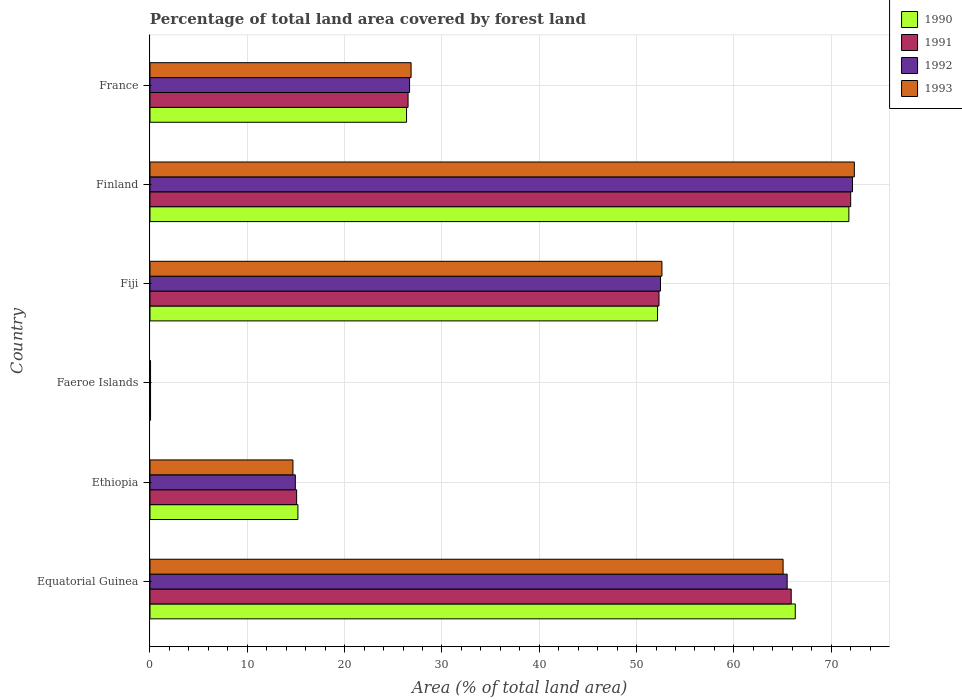How many different coloured bars are there?
Ensure brevity in your answer.  4. How many groups of bars are there?
Provide a short and direct response. 6. Are the number of bars on each tick of the Y-axis equal?
Give a very brief answer. Yes. What is the label of the 4th group of bars from the top?
Give a very brief answer. Faeroe Islands. In how many cases, is the number of bars for a given country not equal to the number of legend labels?
Keep it short and to the point. 0. What is the percentage of forest land in 1990 in Equatorial Guinea?
Your response must be concise. 66.31. Across all countries, what is the maximum percentage of forest land in 1990?
Make the answer very short. 71.82. Across all countries, what is the minimum percentage of forest land in 1993?
Offer a terse response. 0.06. In which country was the percentage of forest land in 1993 maximum?
Your answer should be very brief. Finland. In which country was the percentage of forest land in 1993 minimum?
Offer a very short reply. Faeroe Islands. What is the total percentage of forest land in 1991 in the graph?
Give a very brief answer. 231.85. What is the difference between the percentage of forest land in 1991 in Faeroe Islands and that in Fiji?
Your response must be concise. -52.25. What is the difference between the percentage of forest land in 1991 in Faeroe Islands and the percentage of forest land in 1990 in Finland?
Offer a very short reply. -71.76. What is the average percentage of forest land in 1990 per country?
Your response must be concise. 38.65. What is the difference between the percentage of forest land in 1992 and percentage of forest land in 1991 in Faeroe Islands?
Provide a succinct answer. 0. In how many countries, is the percentage of forest land in 1990 greater than 52 %?
Your answer should be very brief. 3. What is the ratio of the percentage of forest land in 1992 in Equatorial Guinea to that in Fiji?
Your answer should be very brief. 1.25. Is the percentage of forest land in 1991 in Ethiopia less than that in Finland?
Ensure brevity in your answer.  Yes. What is the difference between the highest and the second highest percentage of forest land in 1992?
Provide a short and direct response. 6.72. What is the difference between the highest and the lowest percentage of forest land in 1991?
Make the answer very short. 71.95. Is it the case that in every country, the sum of the percentage of forest land in 1990 and percentage of forest land in 1991 is greater than the sum of percentage of forest land in 1993 and percentage of forest land in 1992?
Offer a terse response. No. What does the 2nd bar from the top in Finland represents?
Provide a succinct answer. 1992. What does the 4th bar from the bottom in Ethiopia represents?
Give a very brief answer. 1993. Is it the case that in every country, the sum of the percentage of forest land in 1990 and percentage of forest land in 1992 is greater than the percentage of forest land in 1993?
Provide a short and direct response. Yes. What is the difference between two consecutive major ticks on the X-axis?
Your answer should be very brief. 10. Are the values on the major ticks of X-axis written in scientific E-notation?
Provide a succinct answer. No. Does the graph contain any zero values?
Your response must be concise. No. How many legend labels are there?
Your response must be concise. 4. How are the legend labels stacked?
Your answer should be very brief. Vertical. What is the title of the graph?
Give a very brief answer. Percentage of total land area covered by forest land. What is the label or title of the X-axis?
Your response must be concise. Area (% of total land area). What is the Area (% of total land area) in 1990 in Equatorial Guinea?
Keep it short and to the point. 66.31. What is the Area (% of total land area) of 1991 in Equatorial Guinea?
Provide a short and direct response. 65.89. What is the Area (% of total land area) in 1992 in Equatorial Guinea?
Your answer should be very brief. 65.48. What is the Area (% of total land area) of 1993 in Equatorial Guinea?
Offer a very short reply. 65.06. What is the Area (% of total land area) in 1990 in Ethiopia?
Give a very brief answer. 15.2. What is the Area (% of total land area) in 1991 in Ethiopia?
Ensure brevity in your answer.  15.07. What is the Area (% of total land area) of 1992 in Ethiopia?
Keep it short and to the point. 14.94. What is the Area (% of total land area) in 1993 in Ethiopia?
Keep it short and to the point. 14.69. What is the Area (% of total land area) of 1990 in Faeroe Islands?
Your answer should be compact. 0.06. What is the Area (% of total land area) in 1991 in Faeroe Islands?
Provide a short and direct response. 0.06. What is the Area (% of total land area) in 1992 in Faeroe Islands?
Your response must be concise. 0.06. What is the Area (% of total land area) in 1993 in Faeroe Islands?
Keep it short and to the point. 0.06. What is the Area (% of total land area) in 1990 in Fiji?
Make the answer very short. 52.16. What is the Area (% of total land area) of 1991 in Fiji?
Your answer should be compact. 52.31. What is the Area (% of total land area) in 1992 in Fiji?
Give a very brief answer. 52.46. What is the Area (% of total land area) in 1993 in Fiji?
Ensure brevity in your answer.  52.61. What is the Area (% of total land area) in 1990 in Finland?
Offer a terse response. 71.82. What is the Area (% of total land area) of 1991 in Finland?
Your response must be concise. 72. What is the Area (% of total land area) of 1992 in Finland?
Offer a terse response. 72.19. What is the Area (% of total land area) of 1993 in Finland?
Your response must be concise. 72.38. What is the Area (% of total land area) of 1990 in France?
Give a very brief answer. 26.36. What is the Area (% of total land area) in 1991 in France?
Ensure brevity in your answer.  26.52. What is the Area (% of total land area) in 1992 in France?
Provide a succinct answer. 26.68. What is the Area (% of total land area) in 1993 in France?
Give a very brief answer. 26.83. Across all countries, what is the maximum Area (% of total land area) in 1990?
Make the answer very short. 71.82. Across all countries, what is the maximum Area (% of total land area) in 1991?
Your answer should be compact. 72. Across all countries, what is the maximum Area (% of total land area) in 1992?
Ensure brevity in your answer.  72.19. Across all countries, what is the maximum Area (% of total land area) in 1993?
Your answer should be very brief. 72.38. Across all countries, what is the minimum Area (% of total land area) in 1990?
Your answer should be compact. 0.06. Across all countries, what is the minimum Area (% of total land area) of 1991?
Keep it short and to the point. 0.06. Across all countries, what is the minimum Area (% of total land area) of 1992?
Provide a short and direct response. 0.06. Across all countries, what is the minimum Area (% of total land area) in 1993?
Give a very brief answer. 0.06. What is the total Area (% of total land area) in 1990 in the graph?
Provide a succinct answer. 231.91. What is the total Area (% of total land area) in 1991 in the graph?
Offer a terse response. 231.85. What is the total Area (% of total land area) of 1992 in the graph?
Your answer should be very brief. 231.79. What is the total Area (% of total land area) in 1993 in the graph?
Make the answer very short. 231.63. What is the difference between the Area (% of total land area) in 1990 in Equatorial Guinea and that in Ethiopia?
Make the answer very short. 51.11. What is the difference between the Area (% of total land area) in 1991 in Equatorial Guinea and that in Ethiopia?
Keep it short and to the point. 50.83. What is the difference between the Area (% of total land area) of 1992 in Equatorial Guinea and that in Ethiopia?
Offer a very short reply. 50.54. What is the difference between the Area (% of total land area) of 1993 in Equatorial Guinea and that in Ethiopia?
Offer a very short reply. 50.37. What is the difference between the Area (% of total land area) in 1990 in Equatorial Guinea and that in Faeroe Islands?
Make the answer very short. 66.25. What is the difference between the Area (% of total land area) in 1991 in Equatorial Guinea and that in Faeroe Islands?
Give a very brief answer. 65.84. What is the difference between the Area (% of total land area) in 1992 in Equatorial Guinea and that in Faeroe Islands?
Your response must be concise. 65.42. What is the difference between the Area (% of total land area) of 1993 in Equatorial Guinea and that in Faeroe Islands?
Your answer should be very brief. 65. What is the difference between the Area (% of total land area) in 1990 in Equatorial Guinea and that in Fiji?
Your answer should be very brief. 14.15. What is the difference between the Area (% of total land area) in 1991 in Equatorial Guinea and that in Fiji?
Offer a terse response. 13.59. What is the difference between the Area (% of total land area) of 1992 in Equatorial Guinea and that in Fiji?
Keep it short and to the point. 13.02. What is the difference between the Area (% of total land area) in 1993 in Equatorial Guinea and that in Fiji?
Your answer should be compact. 12.45. What is the difference between the Area (% of total land area) of 1990 in Equatorial Guinea and that in Finland?
Make the answer very short. -5.51. What is the difference between the Area (% of total land area) of 1991 in Equatorial Guinea and that in Finland?
Offer a very short reply. -6.11. What is the difference between the Area (% of total land area) in 1992 in Equatorial Guinea and that in Finland?
Give a very brief answer. -6.72. What is the difference between the Area (% of total land area) of 1993 in Equatorial Guinea and that in Finland?
Your response must be concise. -7.32. What is the difference between the Area (% of total land area) of 1990 in Equatorial Guinea and that in France?
Your response must be concise. 39.95. What is the difference between the Area (% of total land area) in 1991 in Equatorial Guinea and that in France?
Ensure brevity in your answer.  39.37. What is the difference between the Area (% of total land area) in 1992 in Equatorial Guinea and that in France?
Offer a very short reply. 38.8. What is the difference between the Area (% of total land area) in 1993 in Equatorial Guinea and that in France?
Give a very brief answer. 38.23. What is the difference between the Area (% of total land area) of 1990 in Ethiopia and that in Faeroe Islands?
Your answer should be compact. 15.14. What is the difference between the Area (% of total land area) of 1991 in Ethiopia and that in Faeroe Islands?
Provide a succinct answer. 15.01. What is the difference between the Area (% of total land area) in 1992 in Ethiopia and that in Faeroe Islands?
Ensure brevity in your answer.  14.88. What is the difference between the Area (% of total land area) of 1993 in Ethiopia and that in Faeroe Islands?
Provide a short and direct response. 14.63. What is the difference between the Area (% of total land area) in 1990 in Ethiopia and that in Fiji?
Keep it short and to the point. -36.96. What is the difference between the Area (% of total land area) in 1991 in Ethiopia and that in Fiji?
Provide a succinct answer. -37.24. What is the difference between the Area (% of total land area) of 1992 in Ethiopia and that in Fiji?
Offer a terse response. -37.52. What is the difference between the Area (% of total land area) in 1993 in Ethiopia and that in Fiji?
Make the answer very short. -37.92. What is the difference between the Area (% of total land area) of 1990 in Ethiopia and that in Finland?
Make the answer very short. -56.62. What is the difference between the Area (% of total land area) of 1991 in Ethiopia and that in Finland?
Offer a terse response. -56.94. What is the difference between the Area (% of total land area) in 1992 in Ethiopia and that in Finland?
Provide a short and direct response. -57.26. What is the difference between the Area (% of total land area) in 1993 in Ethiopia and that in Finland?
Offer a very short reply. -57.69. What is the difference between the Area (% of total land area) of 1990 in Ethiopia and that in France?
Your response must be concise. -11.16. What is the difference between the Area (% of total land area) of 1991 in Ethiopia and that in France?
Ensure brevity in your answer.  -11.45. What is the difference between the Area (% of total land area) of 1992 in Ethiopia and that in France?
Make the answer very short. -11.74. What is the difference between the Area (% of total land area) in 1993 in Ethiopia and that in France?
Ensure brevity in your answer.  -12.14. What is the difference between the Area (% of total land area) of 1990 in Faeroe Islands and that in Fiji?
Offer a terse response. -52.1. What is the difference between the Area (% of total land area) of 1991 in Faeroe Islands and that in Fiji?
Your answer should be compact. -52.25. What is the difference between the Area (% of total land area) in 1992 in Faeroe Islands and that in Fiji?
Keep it short and to the point. -52.4. What is the difference between the Area (% of total land area) in 1993 in Faeroe Islands and that in Fiji?
Give a very brief answer. -52.55. What is the difference between the Area (% of total land area) in 1990 in Faeroe Islands and that in Finland?
Your answer should be very brief. -71.76. What is the difference between the Area (% of total land area) in 1991 in Faeroe Islands and that in Finland?
Give a very brief answer. -71.95. What is the difference between the Area (% of total land area) of 1992 in Faeroe Islands and that in Finland?
Provide a succinct answer. -72.13. What is the difference between the Area (% of total land area) of 1993 in Faeroe Islands and that in Finland?
Make the answer very short. -72.32. What is the difference between the Area (% of total land area) of 1990 in Faeroe Islands and that in France?
Your response must be concise. -26.31. What is the difference between the Area (% of total land area) in 1991 in Faeroe Islands and that in France?
Your answer should be compact. -26.46. What is the difference between the Area (% of total land area) in 1992 in Faeroe Islands and that in France?
Ensure brevity in your answer.  -26.62. What is the difference between the Area (% of total land area) in 1993 in Faeroe Islands and that in France?
Provide a short and direct response. -26.77. What is the difference between the Area (% of total land area) of 1990 in Fiji and that in Finland?
Your answer should be compact. -19.66. What is the difference between the Area (% of total land area) of 1991 in Fiji and that in Finland?
Keep it short and to the point. -19.7. What is the difference between the Area (% of total land area) in 1992 in Fiji and that in Finland?
Make the answer very short. -19.73. What is the difference between the Area (% of total land area) in 1993 in Fiji and that in Finland?
Your response must be concise. -19.77. What is the difference between the Area (% of total land area) of 1990 in Fiji and that in France?
Make the answer very short. 25.79. What is the difference between the Area (% of total land area) of 1991 in Fiji and that in France?
Your response must be concise. 25.79. What is the difference between the Area (% of total land area) of 1992 in Fiji and that in France?
Keep it short and to the point. 25.78. What is the difference between the Area (% of total land area) of 1993 in Fiji and that in France?
Offer a terse response. 25.78. What is the difference between the Area (% of total land area) in 1990 in Finland and that in France?
Your answer should be very brief. 45.45. What is the difference between the Area (% of total land area) in 1991 in Finland and that in France?
Give a very brief answer. 45.49. What is the difference between the Area (% of total land area) of 1992 in Finland and that in France?
Offer a terse response. 45.52. What is the difference between the Area (% of total land area) of 1993 in Finland and that in France?
Offer a terse response. 45.55. What is the difference between the Area (% of total land area) in 1990 in Equatorial Guinea and the Area (% of total land area) in 1991 in Ethiopia?
Provide a succinct answer. 51.24. What is the difference between the Area (% of total land area) in 1990 in Equatorial Guinea and the Area (% of total land area) in 1992 in Ethiopia?
Provide a succinct answer. 51.37. What is the difference between the Area (% of total land area) of 1990 in Equatorial Guinea and the Area (% of total land area) of 1993 in Ethiopia?
Provide a short and direct response. 51.62. What is the difference between the Area (% of total land area) of 1991 in Equatorial Guinea and the Area (% of total land area) of 1992 in Ethiopia?
Your answer should be very brief. 50.96. What is the difference between the Area (% of total land area) of 1991 in Equatorial Guinea and the Area (% of total land area) of 1993 in Ethiopia?
Your answer should be compact. 51.2. What is the difference between the Area (% of total land area) in 1992 in Equatorial Guinea and the Area (% of total land area) in 1993 in Ethiopia?
Give a very brief answer. 50.78. What is the difference between the Area (% of total land area) of 1990 in Equatorial Guinea and the Area (% of total land area) of 1991 in Faeroe Islands?
Offer a very short reply. 66.25. What is the difference between the Area (% of total land area) of 1990 in Equatorial Guinea and the Area (% of total land area) of 1992 in Faeroe Islands?
Give a very brief answer. 66.25. What is the difference between the Area (% of total land area) in 1990 in Equatorial Guinea and the Area (% of total land area) in 1993 in Faeroe Islands?
Your answer should be very brief. 66.25. What is the difference between the Area (% of total land area) of 1991 in Equatorial Guinea and the Area (% of total land area) of 1992 in Faeroe Islands?
Your response must be concise. 65.84. What is the difference between the Area (% of total land area) of 1991 in Equatorial Guinea and the Area (% of total land area) of 1993 in Faeroe Islands?
Give a very brief answer. 65.84. What is the difference between the Area (% of total land area) of 1992 in Equatorial Guinea and the Area (% of total land area) of 1993 in Faeroe Islands?
Keep it short and to the point. 65.42. What is the difference between the Area (% of total land area) of 1990 in Equatorial Guinea and the Area (% of total land area) of 1991 in Fiji?
Your answer should be very brief. 14. What is the difference between the Area (% of total land area) of 1990 in Equatorial Guinea and the Area (% of total land area) of 1992 in Fiji?
Keep it short and to the point. 13.85. What is the difference between the Area (% of total land area) in 1990 in Equatorial Guinea and the Area (% of total land area) in 1993 in Fiji?
Your answer should be compact. 13.7. What is the difference between the Area (% of total land area) in 1991 in Equatorial Guinea and the Area (% of total land area) in 1992 in Fiji?
Keep it short and to the point. 13.43. What is the difference between the Area (% of total land area) in 1991 in Equatorial Guinea and the Area (% of total land area) in 1993 in Fiji?
Your answer should be compact. 13.28. What is the difference between the Area (% of total land area) of 1992 in Equatorial Guinea and the Area (% of total land area) of 1993 in Fiji?
Your answer should be compact. 12.87. What is the difference between the Area (% of total land area) of 1990 in Equatorial Guinea and the Area (% of total land area) of 1991 in Finland?
Your response must be concise. -5.69. What is the difference between the Area (% of total land area) in 1990 in Equatorial Guinea and the Area (% of total land area) in 1992 in Finland?
Your response must be concise. -5.88. What is the difference between the Area (% of total land area) in 1990 in Equatorial Guinea and the Area (% of total land area) in 1993 in Finland?
Keep it short and to the point. -6.07. What is the difference between the Area (% of total land area) of 1991 in Equatorial Guinea and the Area (% of total land area) of 1992 in Finland?
Make the answer very short. -6.3. What is the difference between the Area (% of total land area) in 1991 in Equatorial Guinea and the Area (% of total land area) in 1993 in Finland?
Make the answer very short. -6.49. What is the difference between the Area (% of total land area) of 1992 in Equatorial Guinea and the Area (% of total land area) of 1993 in Finland?
Keep it short and to the point. -6.9. What is the difference between the Area (% of total land area) of 1990 in Equatorial Guinea and the Area (% of total land area) of 1991 in France?
Make the answer very short. 39.79. What is the difference between the Area (% of total land area) in 1990 in Equatorial Guinea and the Area (% of total land area) in 1992 in France?
Make the answer very short. 39.63. What is the difference between the Area (% of total land area) in 1990 in Equatorial Guinea and the Area (% of total land area) in 1993 in France?
Make the answer very short. 39.48. What is the difference between the Area (% of total land area) of 1991 in Equatorial Guinea and the Area (% of total land area) of 1992 in France?
Your answer should be very brief. 39.22. What is the difference between the Area (% of total land area) of 1991 in Equatorial Guinea and the Area (% of total land area) of 1993 in France?
Provide a short and direct response. 39.06. What is the difference between the Area (% of total land area) in 1992 in Equatorial Guinea and the Area (% of total land area) in 1993 in France?
Ensure brevity in your answer.  38.64. What is the difference between the Area (% of total land area) of 1990 in Ethiopia and the Area (% of total land area) of 1991 in Faeroe Islands?
Your answer should be very brief. 15.14. What is the difference between the Area (% of total land area) in 1990 in Ethiopia and the Area (% of total land area) in 1992 in Faeroe Islands?
Your answer should be very brief. 15.14. What is the difference between the Area (% of total land area) in 1990 in Ethiopia and the Area (% of total land area) in 1993 in Faeroe Islands?
Give a very brief answer. 15.14. What is the difference between the Area (% of total land area) in 1991 in Ethiopia and the Area (% of total land area) in 1992 in Faeroe Islands?
Your response must be concise. 15.01. What is the difference between the Area (% of total land area) in 1991 in Ethiopia and the Area (% of total land area) in 1993 in Faeroe Islands?
Offer a very short reply. 15.01. What is the difference between the Area (% of total land area) in 1992 in Ethiopia and the Area (% of total land area) in 1993 in Faeroe Islands?
Your response must be concise. 14.88. What is the difference between the Area (% of total land area) in 1990 in Ethiopia and the Area (% of total land area) in 1991 in Fiji?
Give a very brief answer. -37.11. What is the difference between the Area (% of total land area) of 1990 in Ethiopia and the Area (% of total land area) of 1992 in Fiji?
Offer a terse response. -37.26. What is the difference between the Area (% of total land area) in 1990 in Ethiopia and the Area (% of total land area) in 1993 in Fiji?
Ensure brevity in your answer.  -37.41. What is the difference between the Area (% of total land area) in 1991 in Ethiopia and the Area (% of total land area) in 1992 in Fiji?
Offer a terse response. -37.39. What is the difference between the Area (% of total land area) of 1991 in Ethiopia and the Area (% of total land area) of 1993 in Fiji?
Your response must be concise. -37.54. What is the difference between the Area (% of total land area) of 1992 in Ethiopia and the Area (% of total land area) of 1993 in Fiji?
Keep it short and to the point. -37.67. What is the difference between the Area (% of total land area) in 1990 in Ethiopia and the Area (% of total land area) in 1991 in Finland?
Your answer should be compact. -56.81. What is the difference between the Area (% of total land area) of 1990 in Ethiopia and the Area (% of total land area) of 1992 in Finland?
Offer a very short reply. -56.99. What is the difference between the Area (% of total land area) in 1990 in Ethiopia and the Area (% of total land area) in 1993 in Finland?
Your response must be concise. -57.18. What is the difference between the Area (% of total land area) of 1991 in Ethiopia and the Area (% of total land area) of 1992 in Finland?
Your response must be concise. -57.12. What is the difference between the Area (% of total land area) of 1991 in Ethiopia and the Area (% of total land area) of 1993 in Finland?
Your response must be concise. -57.31. What is the difference between the Area (% of total land area) of 1992 in Ethiopia and the Area (% of total land area) of 1993 in Finland?
Give a very brief answer. -57.44. What is the difference between the Area (% of total land area) in 1990 in Ethiopia and the Area (% of total land area) in 1991 in France?
Offer a terse response. -11.32. What is the difference between the Area (% of total land area) of 1990 in Ethiopia and the Area (% of total land area) of 1992 in France?
Give a very brief answer. -11.48. What is the difference between the Area (% of total land area) in 1990 in Ethiopia and the Area (% of total land area) in 1993 in France?
Offer a very short reply. -11.63. What is the difference between the Area (% of total land area) in 1991 in Ethiopia and the Area (% of total land area) in 1992 in France?
Offer a terse response. -11.61. What is the difference between the Area (% of total land area) in 1991 in Ethiopia and the Area (% of total land area) in 1993 in France?
Provide a succinct answer. -11.76. What is the difference between the Area (% of total land area) of 1992 in Ethiopia and the Area (% of total land area) of 1993 in France?
Provide a short and direct response. -11.9. What is the difference between the Area (% of total land area) of 1990 in Faeroe Islands and the Area (% of total land area) of 1991 in Fiji?
Your response must be concise. -52.25. What is the difference between the Area (% of total land area) of 1990 in Faeroe Islands and the Area (% of total land area) of 1992 in Fiji?
Provide a succinct answer. -52.4. What is the difference between the Area (% of total land area) of 1990 in Faeroe Islands and the Area (% of total land area) of 1993 in Fiji?
Ensure brevity in your answer.  -52.55. What is the difference between the Area (% of total land area) of 1991 in Faeroe Islands and the Area (% of total land area) of 1992 in Fiji?
Give a very brief answer. -52.4. What is the difference between the Area (% of total land area) of 1991 in Faeroe Islands and the Area (% of total land area) of 1993 in Fiji?
Keep it short and to the point. -52.55. What is the difference between the Area (% of total land area) of 1992 in Faeroe Islands and the Area (% of total land area) of 1993 in Fiji?
Your response must be concise. -52.55. What is the difference between the Area (% of total land area) in 1990 in Faeroe Islands and the Area (% of total land area) in 1991 in Finland?
Offer a very short reply. -71.95. What is the difference between the Area (% of total land area) of 1990 in Faeroe Islands and the Area (% of total land area) of 1992 in Finland?
Provide a succinct answer. -72.13. What is the difference between the Area (% of total land area) in 1990 in Faeroe Islands and the Area (% of total land area) in 1993 in Finland?
Your answer should be compact. -72.32. What is the difference between the Area (% of total land area) of 1991 in Faeroe Islands and the Area (% of total land area) of 1992 in Finland?
Keep it short and to the point. -72.13. What is the difference between the Area (% of total land area) in 1991 in Faeroe Islands and the Area (% of total land area) in 1993 in Finland?
Offer a very short reply. -72.32. What is the difference between the Area (% of total land area) in 1992 in Faeroe Islands and the Area (% of total land area) in 1993 in Finland?
Keep it short and to the point. -72.32. What is the difference between the Area (% of total land area) of 1990 in Faeroe Islands and the Area (% of total land area) of 1991 in France?
Make the answer very short. -26.46. What is the difference between the Area (% of total land area) of 1990 in Faeroe Islands and the Area (% of total land area) of 1992 in France?
Your answer should be very brief. -26.62. What is the difference between the Area (% of total land area) in 1990 in Faeroe Islands and the Area (% of total land area) in 1993 in France?
Provide a succinct answer. -26.77. What is the difference between the Area (% of total land area) in 1991 in Faeroe Islands and the Area (% of total land area) in 1992 in France?
Your response must be concise. -26.62. What is the difference between the Area (% of total land area) in 1991 in Faeroe Islands and the Area (% of total land area) in 1993 in France?
Your response must be concise. -26.77. What is the difference between the Area (% of total land area) of 1992 in Faeroe Islands and the Area (% of total land area) of 1993 in France?
Your response must be concise. -26.77. What is the difference between the Area (% of total land area) of 1990 in Fiji and the Area (% of total land area) of 1991 in Finland?
Provide a succinct answer. -19.85. What is the difference between the Area (% of total land area) of 1990 in Fiji and the Area (% of total land area) of 1992 in Finland?
Provide a succinct answer. -20.04. What is the difference between the Area (% of total land area) of 1990 in Fiji and the Area (% of total land area) of 1993 in Finland?
Your answer should be very brief. -20.22. What is the difference between the Area (% of total land area) in 1991 in Fiji and the Area (% of total land area) in 1992 in Finland?
Make the answer very short. -19.89. What is the difference between the Area (% of total land area) of 1991 in Fiji and the Area (% of total land area) of 1993 in Finland?
Offer a terse response. -20.07. What is the difference between the Area (% of total land area) in 1992 in Fiji and the Area (% of total land area) in 1993 in Finland?
Make the answer very short. -19.92. What is the difference between the Area (% of total land area) in 1990 in Fiji and the Area (% of total land area) in 1991 in France?
Give a very brief answer. 25.64. What is the difference between the Area (% of total land area) in 1990 in Fiji and the Area (% of total land area) in 1992 in France?
Provide a short and direct response. 25.48. What is the difference between the Area (% of total land area) in 1990 in Fiji and the Area (% of total land area) in 1993 in France?
Offer a terse response. 25.33. What is the difference between the Area (% of total land area) of 1991 in Fiji and the Area (% of total land area) of 1992 in France?
Your answer should be compact. 25.63. What is the difference between the Area (% of total land area) of 1991 in Fiji and the Area (% of total land area) of 1993 in France?
Your answer should be compact. 25.48. What is the difference between the Area (% of total land area) in 1992 in Fiji and the Area (% of total land area) in 1993 in France?
Your answer should be very brief. 25.63. What is the difference between the Area (% of total land area) in 1990 in Finland and the Area (% of total land area) in 1991 in France?
Make the answer very short. 45.3. What is the difference between the Area (% of total land area) in 1990 in Finland and the Area (% of total land area) in 1992 in France?
Your answer should be very brief. 45.14. What is the difference between the Area (% of total land area) in 1990 in Finland and the Area (% of total land area) in 1993 in France?
Your response must be concise. 44.99. What is the difference between the Area (% of total land area) of 1991 in Finland and the Area (% of total land area) of 1992 in France?
Your response must be concise. 45.33. What is the difference between the Area (% of total land area) in 1991 in Finland and the Area (% of total land area) in 1993 in France?
Make the answer very short. 45.17. What is the difference between the Area (% of total land area) in 1992 in Finland and the Area (% of total land area) in 1993 in France?
Offer a terse response. 45.36. What is the average Area (% of total land area) in 1990 per country?
Give a very brief answer. 38.65. What is the average Area (% of total land area) in 1991 per country?
Offer a terse response. 38.64. What is the average Area (% of total land area) of 1992 per country?
Give a very brief answer. 38.63. What is the average Area (% of total land area) of 1993 per country?
Your answer should be very brief. 38.6. What is the difference between the Area (% of total land area) in 1990 and Area (% of total land area) in 1991 in Equatorial Guinea?
Your answer should be compact. 0.42. What is the difference between the Area (% of total land area) in 1990 and Area (% of total land area) in 1992 in Equatorial Guinea?
Your answer should be very brief. 0.83. What is the difference between the Area (% of total land area) in 1990 and Area (% of total land area) in 1993 in Equatorial Guinea?
Your answer should be compact. 1.25. What is the difference between the Area (% of total land area) in 1991 and Area (% of total land area) in 1992 in Equatorial Guinea?
Your answer should be compact. 0.42. What is the difference between the Area (% of total land area) of 1991 and Area (% of total land area) of 1993 in Equatorial Guinea?
Make the answer very short. 0.83. What is the difference between the Area (% of total land area) in 1992 and Area (% of total land area) in 1993 in Equatorial Guinea?
Provide a short and direct response. 0.42. What is the difference between the Area (% of total land area) of 1990 and Area (% of total land area) of 1991 in Ethiopia?
Keep it short and to the point. 0.13. What is the difference between the Area (% of total land area) in 1990 and Area (% of total land area) in 1992 in Ethiopia?
Ensure brevity in your answer.  0.26. What is the difference between the Area (% of total land area) of 1990 and Area (% of total land area) of 1993 in Ethiopia?
Give a very brief answer. 0.51. What is the difference between the Area (% of total land area) in 1991 and Area (% of total land area) in 1992 in Ethiopia?
Offer a very short reply. 0.13. What is the difference between the Area (% of total land area) in 1991 and Area (% of total land area) in 1993 in Ethiopia?
Give a very brief answer. 0.38. What is the difference between the Area (% of total land area) in 1992 and Area (% of total land area) in 1993 in Ethiopia?
Your response must be concise. 0.24. What is the difference between the Area (% of total land area) in 1990 and Area (% of total land area) in 1992 in Faeroe Islands?
Your answer should be very brief. 0. What is the difference between the Area (% of total land area) of 1991 and Area (% of total land area) of 1992 in Faeroe Islands?
Offer a terse response. 0. What is the difference between the Area (% of total land area) in 1991 and Area (% of total land area) in 1993 in Faeroe Islands?
Ensure brevity in your answer.  0. What is the difference between the Area (% of total land area) in 1990 and Area (% of total land area) in 1991 in Fiji?
Offer a very short reply. -0.15. What is the difference between the Area (% of total land area) of 1990 and Area (% of total land area) of 1992 in Fiji?
Offer a terse response. -0.3. What is the difference between the Area (% of total land area) of 1990 and Area (% of total land area) of 1993 in Fiji?
Ensure brevity in your answer.  -0.45. What is the difference between the Area (% of total land area) in 1991 and Area (% of total land area) in 1992 in Fiji?
Ensure brevity in your answer.  -0.15. What is the difference between the Area (% of total land area) in 1991 and Area (% of total land area) in 1993 in Fiji?
Offer a terse response. -0.3. What is the difference between the Area (% of total land area) in 1992 and Area (% of total land area) in 1993 in Fiji?
Make the answer very short. -0.15. What is the difference between the Area (% of total land area) in 1990 and Area (% of total land area) in 1991 in Finland?
Ensure brevity in your answer.  -0.19. What is the difference between the Area (% of total land area) in 1990 and Area (% of total land area) in 1992 in Finland?
Your answer should be compact. -0.37. What is the difference between the Area (% of total land area) in 1990 and Area (% of total land area) in 1993 in Finland?
Your answer should be compact. -0.56. What is the difference between the Area (% of total land area) in 1991 and Area (% of total land area) in 1992 in Finland?
Make the answer very short. -0.19. What is the difference between the Area (% of total land area) of 1991 and Area (% of total land area) of 1993 in Finland?
Your answer should be very brief. -0.37. What is the difference between the Area (% of total land area) in 1992 and Area (% of total land area) in 1993 in Finland?
Provide a succinct answer. -0.19. What is the difference between the Area (% of total land area) of 1990 and Area (% of total land area) of 1991 in France?
Provide a succinct answer. -0.16. What is the difference between the Area (% of total land area) of 1990 and Area (% of total land area) of 1992 in France?
Provide a succinct answer. -0.31. What is the difference between the Area (% of total land area) in 1990 and Area (% of total land area) in 1993 in France?
Your response must be concise. -0.47. What is the difference between the Area (% of total land area) in 1991 and Area (% of total land area) in 1992 in France?
Provide a succinct answer. -0.16. What is the difference between the Area (% of total land area) in 1991 and Area (% of total land area) in 1993 in France?
Your answer should be compact. -0.31. What is the difference between the Area (% of total land area) of 1992 and Area (% of total land area) of 1993 in France?
Ensure brevity in your answer.  -0.16. What is the ratio of the Area (% of total land area) in 1990 in Equatorial Guinea to that in Ethiopia?
Your answer should be very brief. 4.36. What is the ratio of the Area (% of total land area) in 1991 in Equatorial Guinea to that in Ethiopia?
Ensure brevity in your answer.  4.37. What is the ratio of the Area (% of total land area) of 1992 in Equatorial Guinea to that in Ethiopia?
Provide a succinct answer. 4.38. What is the ratio of the Area (% of total land area) of 1993 in Equatorial Guinea to that in Ethiopia?
Your answer should be very brief. 4.43. What is the ratio of the Area (% of total land area) in 1990 in Equatorial Guinea to that in Faeroe Islands?
Your answer should be very brief. 1157.11. What is the ratio of the Area (% of total land area) of 1991 in Equatorial Guinea to that in Faeroe Islands?
Provide a succinct answer. 1149.83. What is the ratio of the Area (% of total land area) in 1992 in Equatorial Guinea to that in Faeroe Islands?
Offer a terse response. 1142.56. What is the ratio of the Area (% of total land area) in 1993 in Equatorial Guinea to that in Faeroe Islands?
Your response must be concise. 1135.28. What is the ratio of the Area (% of total land area) in 1990 in Equatorial Guinea to that in Fiji?
Give a very brief answer. 1.27. What is the ratio of the Area (% of total land area) in 1991 in Equatorial Guinea to that in Fiji?
Ensure brevity in your answer.  1.26. What is the ratio of the Area (% of total land area) in 1992 in Equatorial Guinea to that in Fiji?
Ensure brevity in your answer.  1.25. What is the ratio of the Area (% of total land area) in 1993 in Equatorial Guinea to that in Fiji?
Provide a short and direct response. 1.24. What is the ratio of the Area (% of total land area) of 1990 in Equatorial Guinea to that in Finland?
Offer a terse response. 0.92. What is the ratio of the Area (% of total land area) of 1991 in Equatorial Guinea to that in Finland?
Provide a succinct answer. 0.92. What is the ratio of the Area (% of total land area) of 1992 in Equatorial Guinea to that in Finland?
Make the answer very short. 0.91. What is the ratio of the Area (% of total land area) of 1993 in Equatorial Guinea to that in Finland?
Your answer should be compact. 0.9. What is the ratio of the Area (% of total land area) in 1990 in Equatorial Guinea to that in France?
Provide a short and direct response. 2.52. What is the ratio of the Area (% of total land area) of 1991 in Equatorial Guinea to that in France?
Keep it short and to the point. 2.48. What is the ratio of the Area (% of total land area) in 1992 in Equatorial Guinea to that in France?
Keep it short and to the point. 2.45. What is the ratio of the Area (% of total land area) of 1993 in Equatorial Guinea to that in France?
Provide a succinct answer. 2.42. What is the ratio of the Area (% of total land area) in 1990 in Ethiopia to that in Faeroe Islands?
Offer a very short reply. 265.24. What is the ratio of the Area (% of total land area) of 1991 in Ethiopia to that in Faeroe Islands?
Offer a very short reply. 262.93. What is the ratio of the Area (% of total land area) of 1992 in Ethiopia to that in Faeroe Islands?
Keep it short and to the point. 260.63. What is the ratio of the Area (% of total land area) of 1993 in Ethiopia to that in Faeroe Islands?
Keep it short and to the point. 256.36. What is the ratio of the Area (% of total land area) of 1990 in Ethiopia to that in Fiji?
Offer a terse response. 0.29. What is the ratio of the Area (% of total land area) in 1991 in Ethiopia to that in Fiji?
Ensure brevity in your answer.  0.29. What is the ratio of the Area (% of total land area) in 1992 in Ethiopia to that in Fiji?
Provide a succinct answer. 0.28. What is the ratio of the Area (% of total land area) of 1993 in Ethiopia to that in Fiji?
Provide a short and direct response. 0.28. What is the ratio of the Area (% of total land area) in 1990 in Ethiopia to that in Finland?
Keep it short and to the point. 0.21. What is the ratio of the Area (% of total land area) of 1991 in Ethiopia to that in Finland?
Your answer should be very brief. 0.21. What is the ratio of the Area (% of total land area) in 1992 in Ethiopia to that in Finland?
Your answer should be very brief. 0.21. What is the ratio of the Area (% of total land area) in 1993 in Ethiopia to that in Finland?
Keep it short and to the point. 0.2. What is the ratio of the Area (% of total land area) in 1990 in Ethiopia to that in France?
Provide a succinct answer. 0.58. What is the ratio of the Area (% of total land area) of 1991 in Ethiopia to that in France?
Your response must be concise. 0.57. What is the ratio of the Area (% of total land area) of 1992 in Ethiopia to that in France?
Give a very brief answer. 0.56. What is the ratio of the Area (% of total land area) in 1993 in Ethiopia to that in France?
Keep it short and to the point. 0.55. What is the ratio of the Area (% of total land area) in 1990 in Faeroe Islands to that in Fiji?
Make the answer very short. 0. What is the ratio of the Area (% of total land area) of 1991 in Faeroe Islands to that in Fiji?
Give a very brief answer. 0. What is the ratio of the Area (% of total land area) in 1992 in Faeroe Islands to that in Fiji?
Your answer should be compact. 0. What is the ratio of the Area (% of total land area) in 1993 in Faeroe Islands to that in Fiji?
Provide a succinct answer. 0. What is the ratio of the Area (% of total land area) in 1990 in Faeroe Islands to that in Finland?
Ensure brevity in your answer.  0. What is the ratio of the Area (% of total land area) in 1991 in Faeroe Islands to that in Finland?
Your answer should be very brief. 0. What is the ratio of the Area (% of total land area) in 1992 in Faeroe Islands to that in Finland?
Your answer should be very brief. 0. What is the ratio of the Area (% of total land area) of 1993 in Faeroe Islands to that in Finland?
Keep it short and to the point. 0. What is the ratio of the Area (% of total land area) of 1990 in Faeroe Islands to that in France?
Provide a succinct answer. 0. What is the ratio of the Area (% of total land area) of 1991 in Faeroe Islands to that in France?
Offer a very short reply. 0. What is the ratio of the Area (% of total land area) of 1992 in Faeroe Islands to that in France?
Provide a short and direct response. 0. What is the ratio of the Area (% of total land area) in 1993 in Faeroe Islands to that in France?
Offer a terse response. 0. What is the ratio of the Area (% of total land area) of 1990 in Fiji to that in Finland?
Give a very brief answer. 0.73. What is the ratio of the Area (% of total land area) of 1991 in Fiji to that in Finland?
Give a very brief answer. 0.73. What is the ratio of the Area (% of total land area) in 1992 in Fiji to that in Finland?
Give a very brief answer. 0.73. What is the ratio of the Area (% of total land area) of 1993 in Fiji to that in Finland?
Your answer should be very brief. 0.73. What is the ratio of the Area (% of total land area) of 1990 in Fiji to that in France?
Give a very brief answer. 1.98. What is the ratio of the Area (% of total land area) in 1991 in Fiji to that in France?
Keep it short and to the point. 1.97. What is the ratio of the Area (% of total land area) of 1992 in Fiji to that in France?
Your response must be concise. 1.97. What is the ratio of the Area (% of total land area) in 1993 in Fiji to that in France?
Offer a very short reply. 1.96. What is the ratio of the Area (% of total land area) of 1990 in Finland to that in France?
Offer a very short reply. 2.72. What is the ratio of the Area (% of total land area) of 1991 in Finland to that in France?
Make the answer very short. 2.72. What is the ratio of the Area (% of total land area) of 1992 in Finland to that in France?
Keep it short and to the point. 2.71. What is the ratio of the Area (% of total land area) of 1993 in Finland to that in France?
Make the answer very short. 2.7. What is the difference between the highest and the second highest Area (% of total land area) in 1990?
Ensure brevity in your answer.  5.51. What is the difference between the highest and the second highest Area (% of total land area) of 1991?
Offer a terse response. 6.11. What is the difference between the highest and the second highest Area (% of total land area) in 1992?
Make the answer very short. 6.72. What is the difference between the highest and the second highest Area (% of total land area) of 1993?
Your response must be concise. 7.32. What is the difference between the highest and the lowest Area (% of total land area) of 1990?
Give a very brief answer. 71.76. What is the difference between the highest and the lowest Area (% of total land area) in 1991?
Offer a terse response. 71.95. What is the difference between the highest and the lowest Area (% of total land area) of 1992?
Your response must be concise. 72.13. What is the difference between the highest and the lowest Area (% of total land area) in 1993?
Provide a short and direct response. 72.32. 